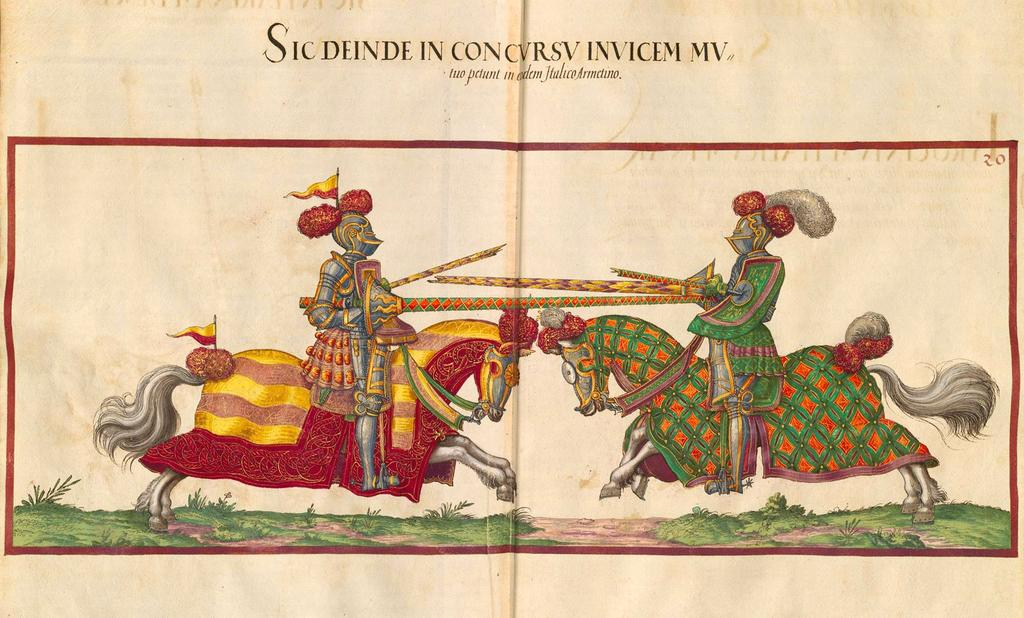What is featured on the poster in the image? The poster depicts persons sitting on horses. What type of vegetation can be seen in the image? There are plants visible in the image. What is the surface covered with in the image? There is grass on a surface in the image. What is written or displayed at the top of the image? There is text present at the top of the image. Reasoning: Let's think step by step by step in order to produce the conversation. We start by identifying the main subject of the image, which is the poster. Then, we describe the content of the poster, focusing on the persons sitting on horses. Next, we mention the presence of plants and grass, which provide context for the setting. Finally, we acknowledge the text at the top of the image, which may provide additional information or context. Absurd Question/Answer: Where is the throne located in the image? There is no throne present in the image. What type of jelly can be seen dripping from the plants in the image? There is no jelly present in the image; the plants are not depicted as having any liquid or substance dripping from them. 